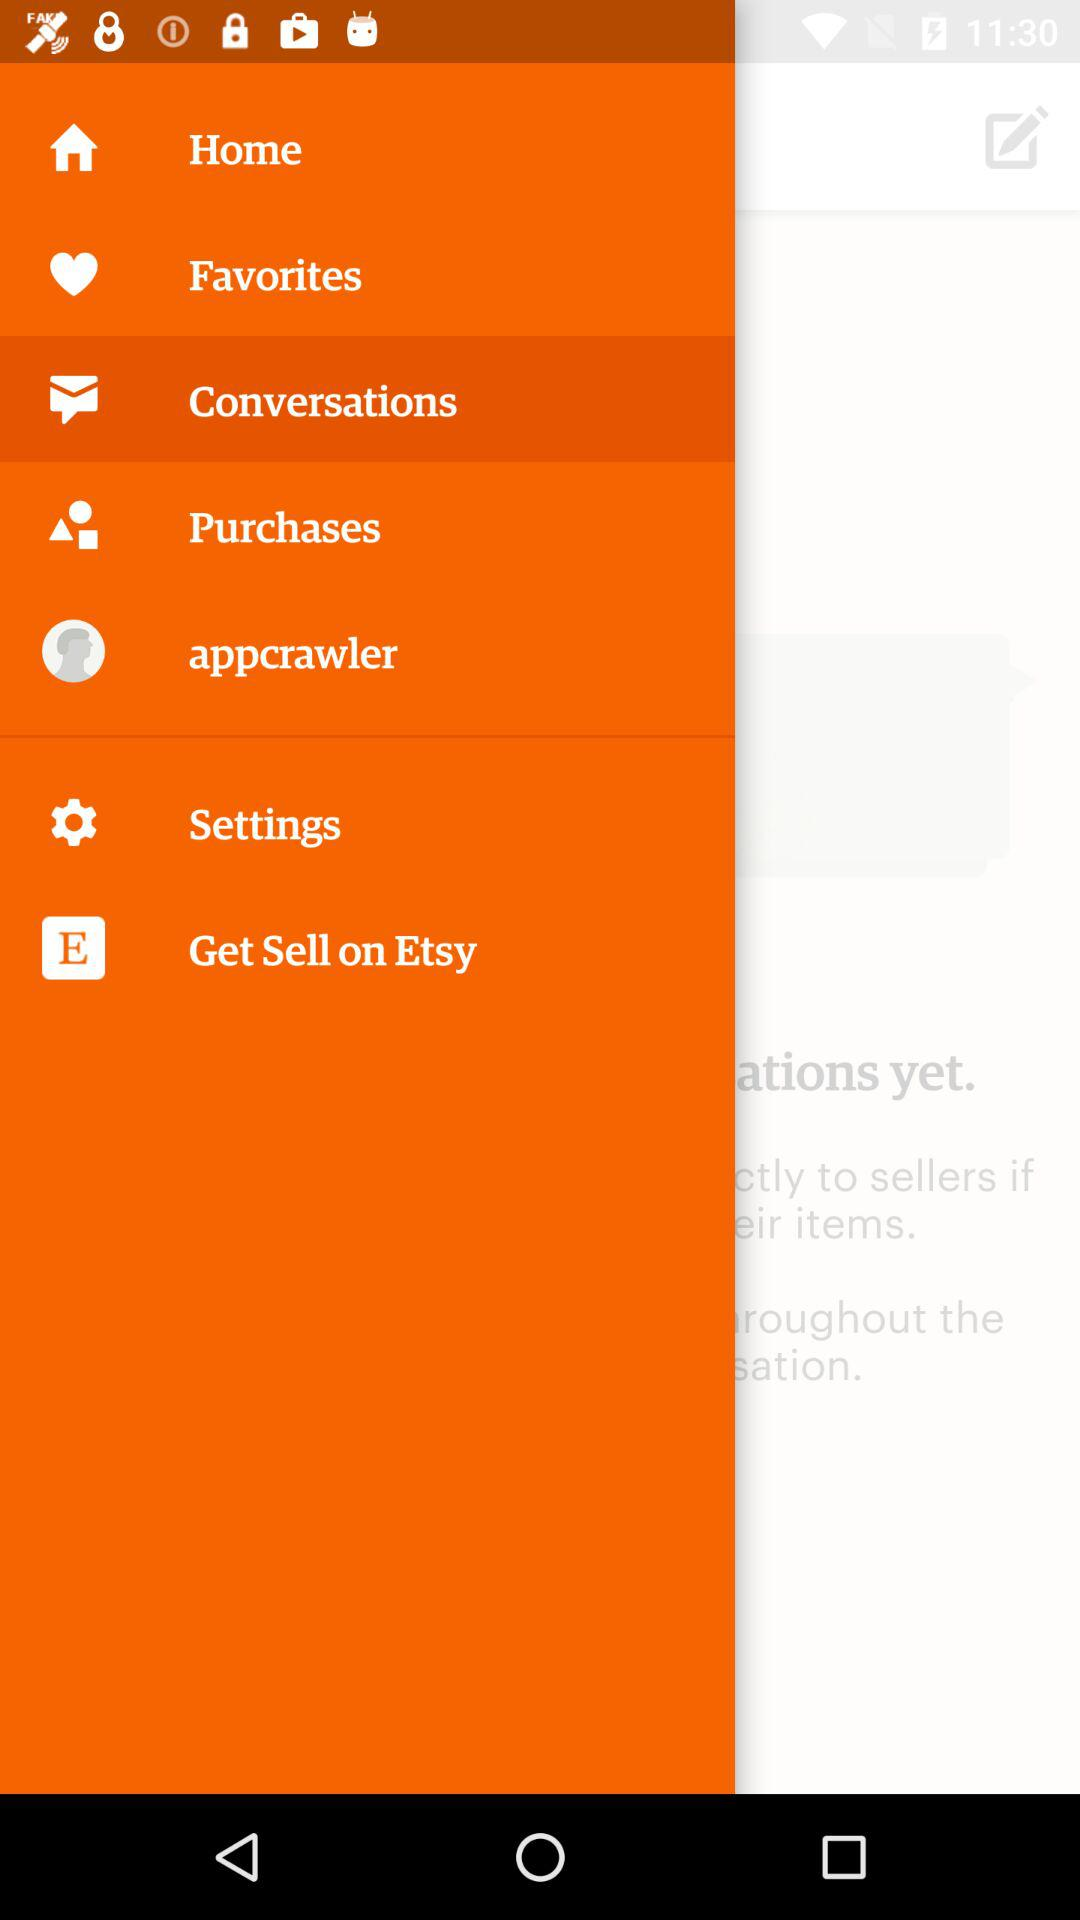What is the username? The username is "appcrawler". 